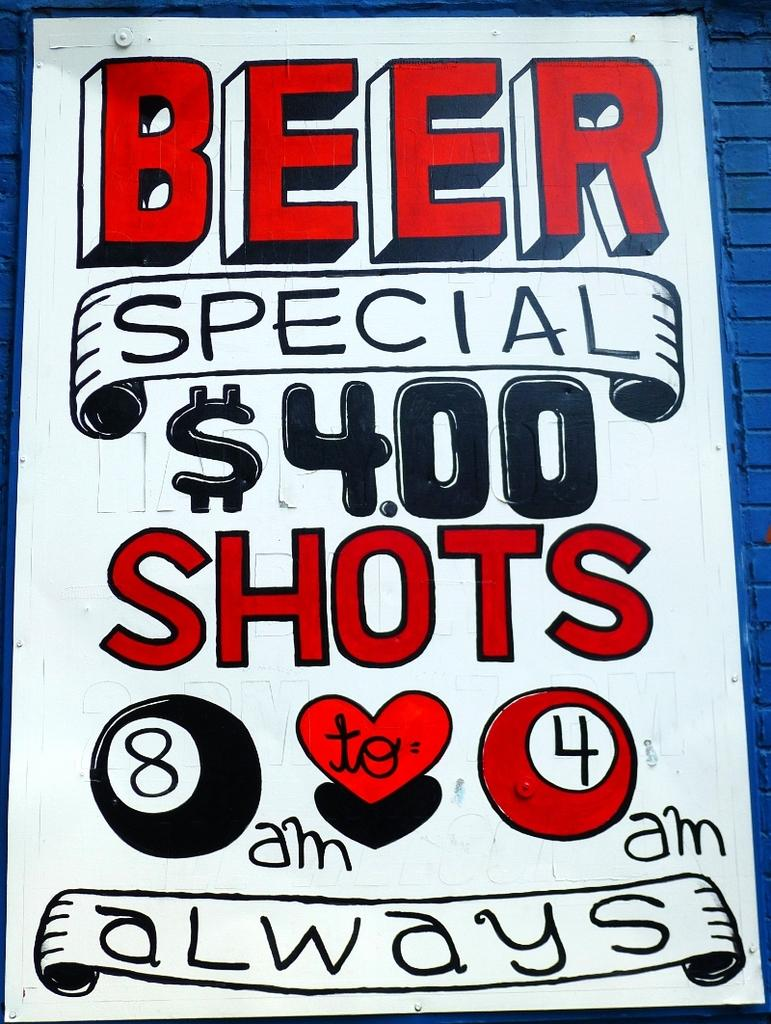Provide a one-sentence caption for the provided image. The poster displays $4.00 shots from 8am - 4am on a daily basis. 